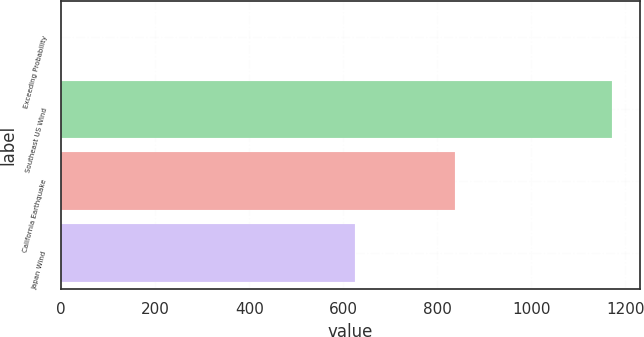Convert chart to OTSL. <chart><loc_0><loc_0><loc_500><loc_500><bar_chart><fcel>Exceeding Probability<fcel>Southeast US Wind<fcel>California Earthquake<fcel>Japan Wind<nl><fcel>0.4<fcel>1172<fcel>838<fcel>625<nl></chart> 